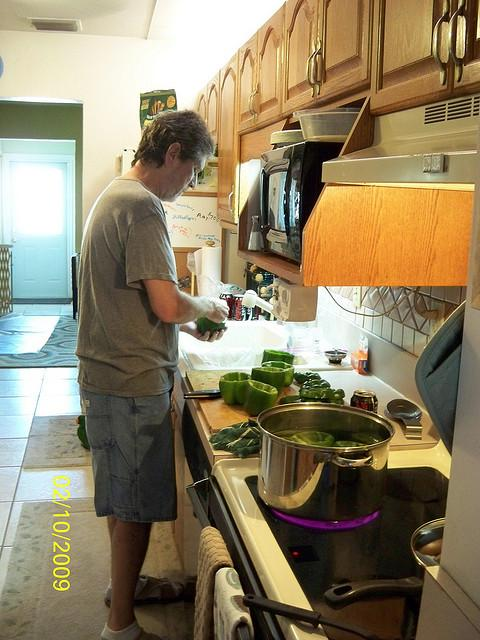What is the person cooking on the stove? Please explain your reasoning. green peppers. The person is preparing bell shaped vegetables that are the color of grass. 